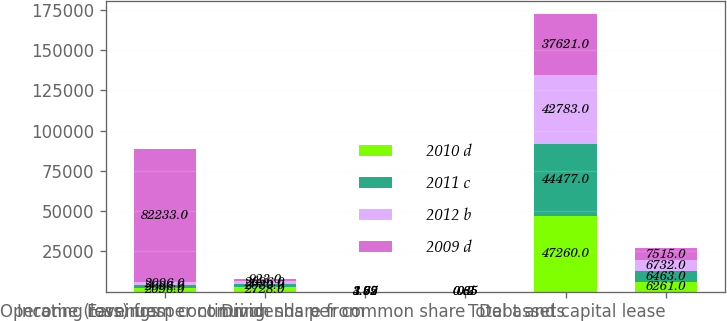<chart> <loc_0><loc_0><loc_500><loc_500><stacked_bar_chart><ecel><fcel>Operating revenues<fcel>Income (loss) from continuing<fcel>Earnings per common share from<fcel>Dividends per common share<fcel>Total assets<fcel>Debt and capital lease<nl><fcel>2010 d<fcel>2096<fcel>2728<fcel>4.97<fcel>0.85<fcel>47260<fcel>6261<nl><fcel>2011 c<fcel>2096<fcel>2080<fcel>3.75<fcel>0.65<fcel>44477<fcel>6463<nl><fcel>2012 b<fcel>2096<fcel>2096<fcel>3.69<fcel>0.3<fcel>42783<fcel>6732<nl><fcel>2009 d<fcel>82233<fcel>923<fcel>1.62<fcel>0.2<fcel>37621<fcel>7515<nl></chart> 